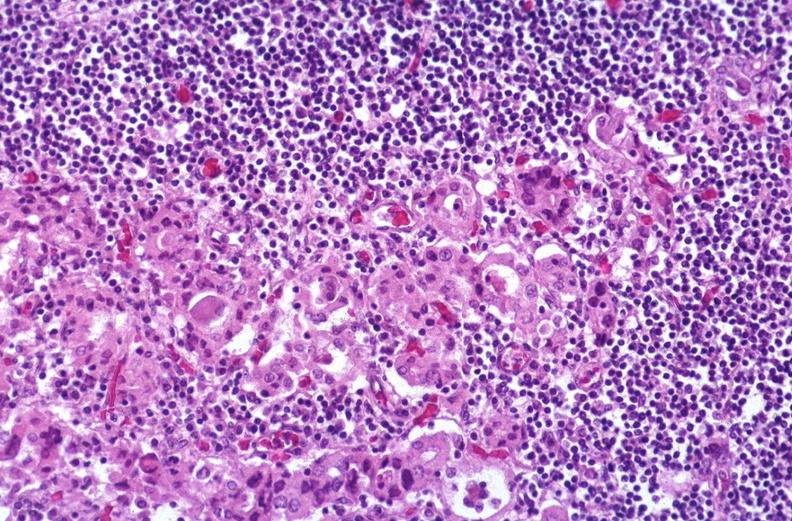does hemorrhage associated with placental abruption show hashimoto 's thyroiditis?
Answer the question using a single word or phrase. No 